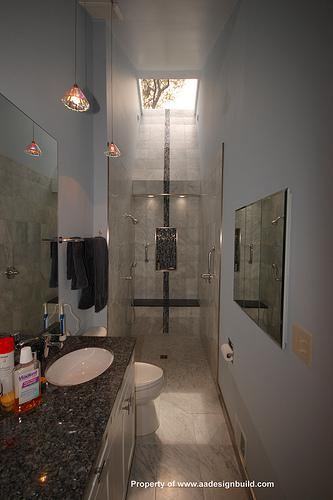Question: what room is this?
Choices:
A. A bathroom.
B. A bedroom.
C. A living room.
D. A kitchen.
Answer with the letter. Answer: A Question: why is there a shower?
Choices:
A. It's a bathroom.
B. For someone to clean themselves.
C. It's a locker room.
D. To wash in.
Answer with the letter. Answer: B Question: what color are the hanging towels?
Choices:
A. Blue.
B. White.
C. Dark gray.
D. Red.
Answer with the letter. Answer: C Question: who might have taken this picture?
Choices:
A. The landlord.
B. The owner of the bathroom.
C. The man.
D. The wife.
Answer with the letter. Answer: B 